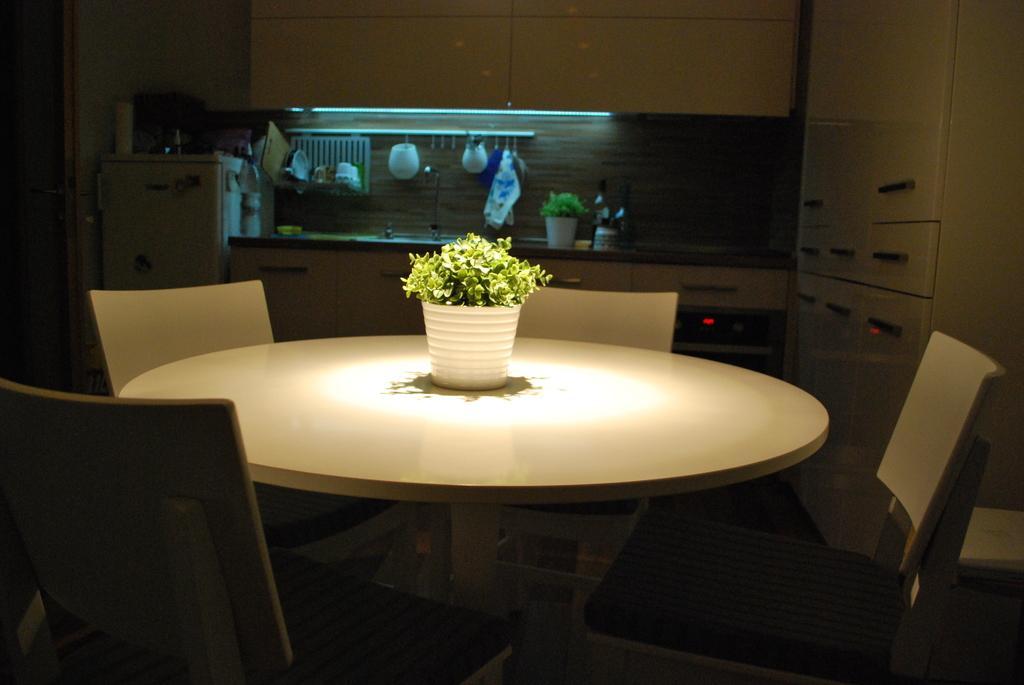Could you give a brief overview of what you see in this image? It is a kitchen there is a table and there are four chairs around the table, there is a small plant placed on the table ,behind it there is a kitchen floor some utensils are kept on it,to the left side there is a fridge ,in the background there are some cupboards and a wall. 